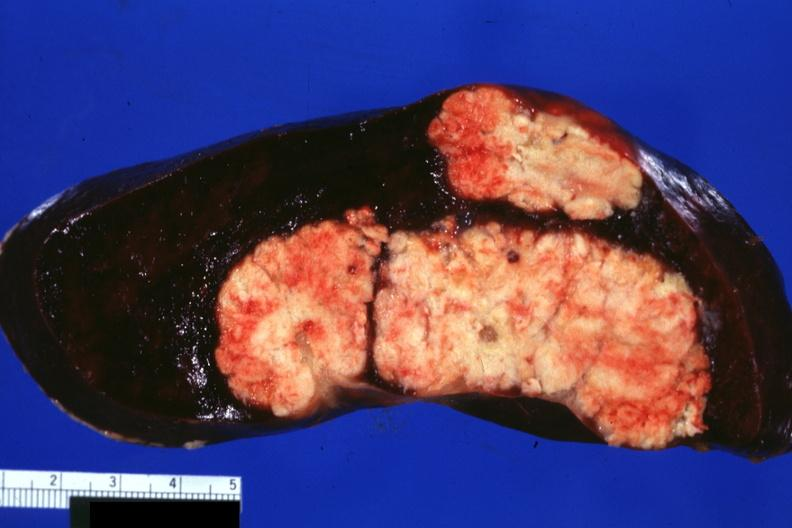s hematologic present?
Answer the question using a single word or phrase. Yes 